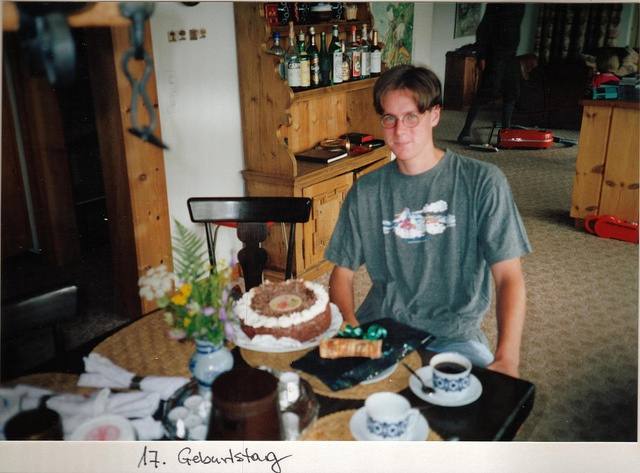Describe the objects in this image and their specific colors. I can see dining table in darkgray, black, olive, and lightgray tones, people in darkgray, gray, teal, black, and tan tones, potted plant in darkgray, darkgreen, and gray tones, chair in darkgray, black, and maroon tones, and cake in darkgray, gray, lightgray, and tan tones in this image. 